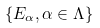<formula> <loc_0><loc_0><loc_500><loc_500>\{ E _ { \alpha } , \alpha \in \Lambda \}</formula> 